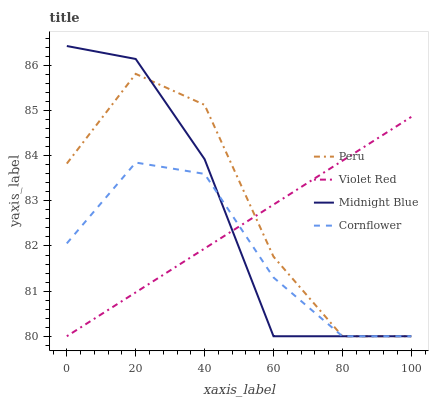Does Cornflower have the minimum area under the curve?
Answer yes or no. Yes. Does Peru have the maximum area under the curve?
Answer yes or no. Yes. Does Violet Red have the minimum area under the curve?
Answer yes or no. No. Does Violet Red have the maximum area under the curve?
Answer yes or no. No. Is Violet Red the smoothest?
Answer yes or no. Yes. Is Peru the roughest?
Answer yes or no. Yes. Is Midnight Blue the smoothest?
Answer yes or no. No. Is Midnight Blue the roughest?
Answer yes or no. No. Does Cornflower have the lowest value?
Answer yes or no. Yes. Does Midnight Blue have the highest value?
Answer yes or no. Yes. Does Violet Red have the highest value?
Answer yes or no. No. Does Peru intersect Cornflower?
Answer yes or no. Yes. Is Peru less than Cornflower?
Answer yes or no. No. Is Peru greater than Cornflower?
Answer yes or no. No. 